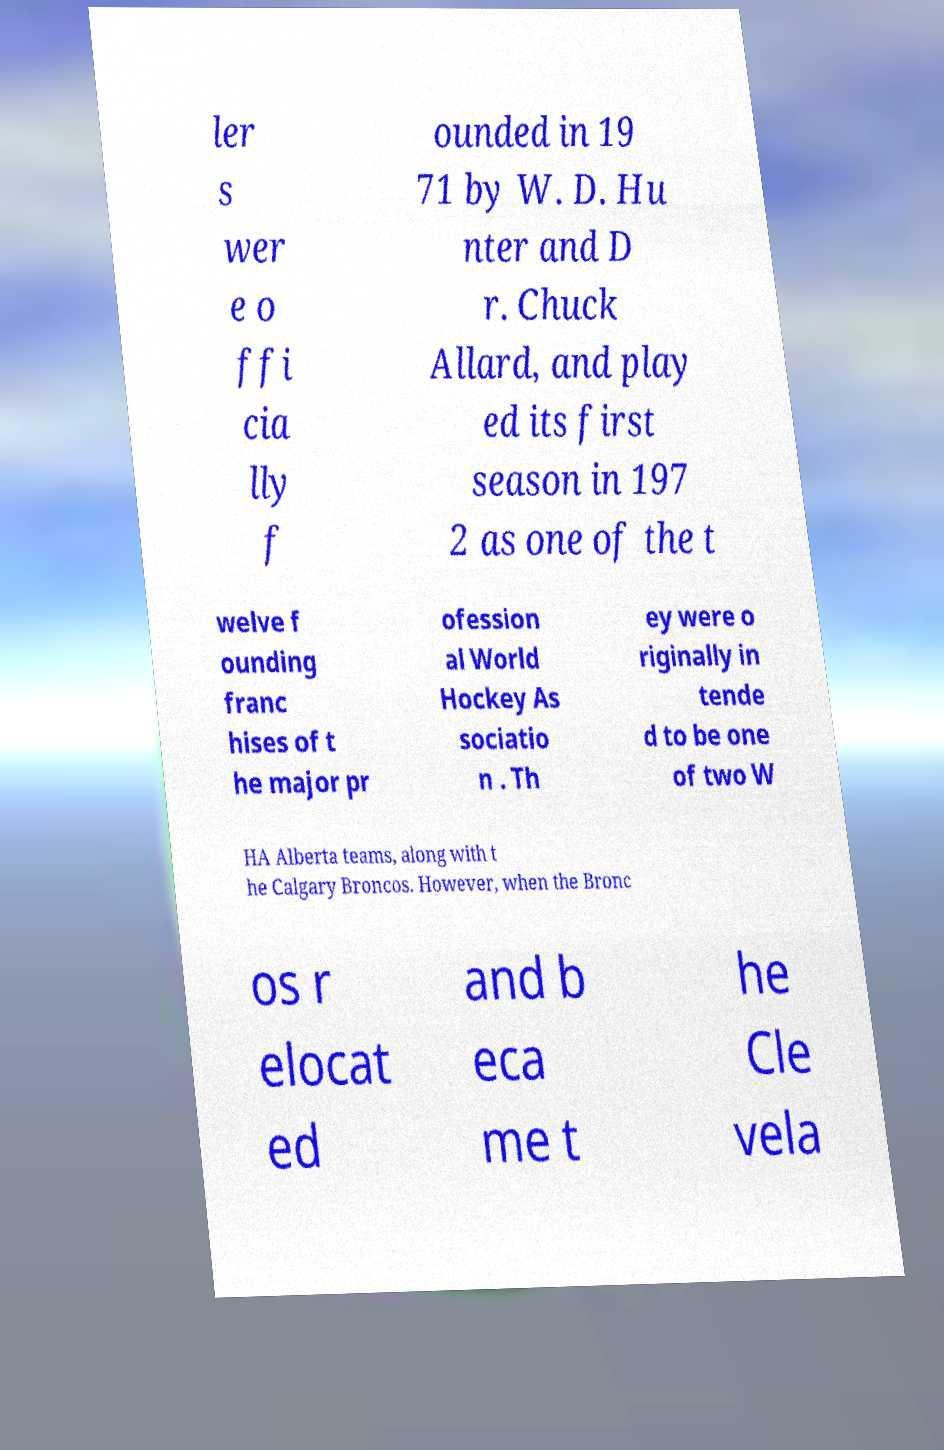There's text embedded in this image that I need extracted. Can you transcribe it verbatim? ler s wer e o ffi cia lly f ounded in 19 71 by W. D. Hu nter and D r. Chuck Allard, and play ed its first season in 197 2 as one of the t welve f ounding franc hises of t he major pr ofession al World Hockey As sociatio n . Th ey were o riginally in tende d to be one of two W HA Alberta teams, along with t he Calgary Broncos. However, when the Bronc os r elocat ed and b eca me t he Cle vela 